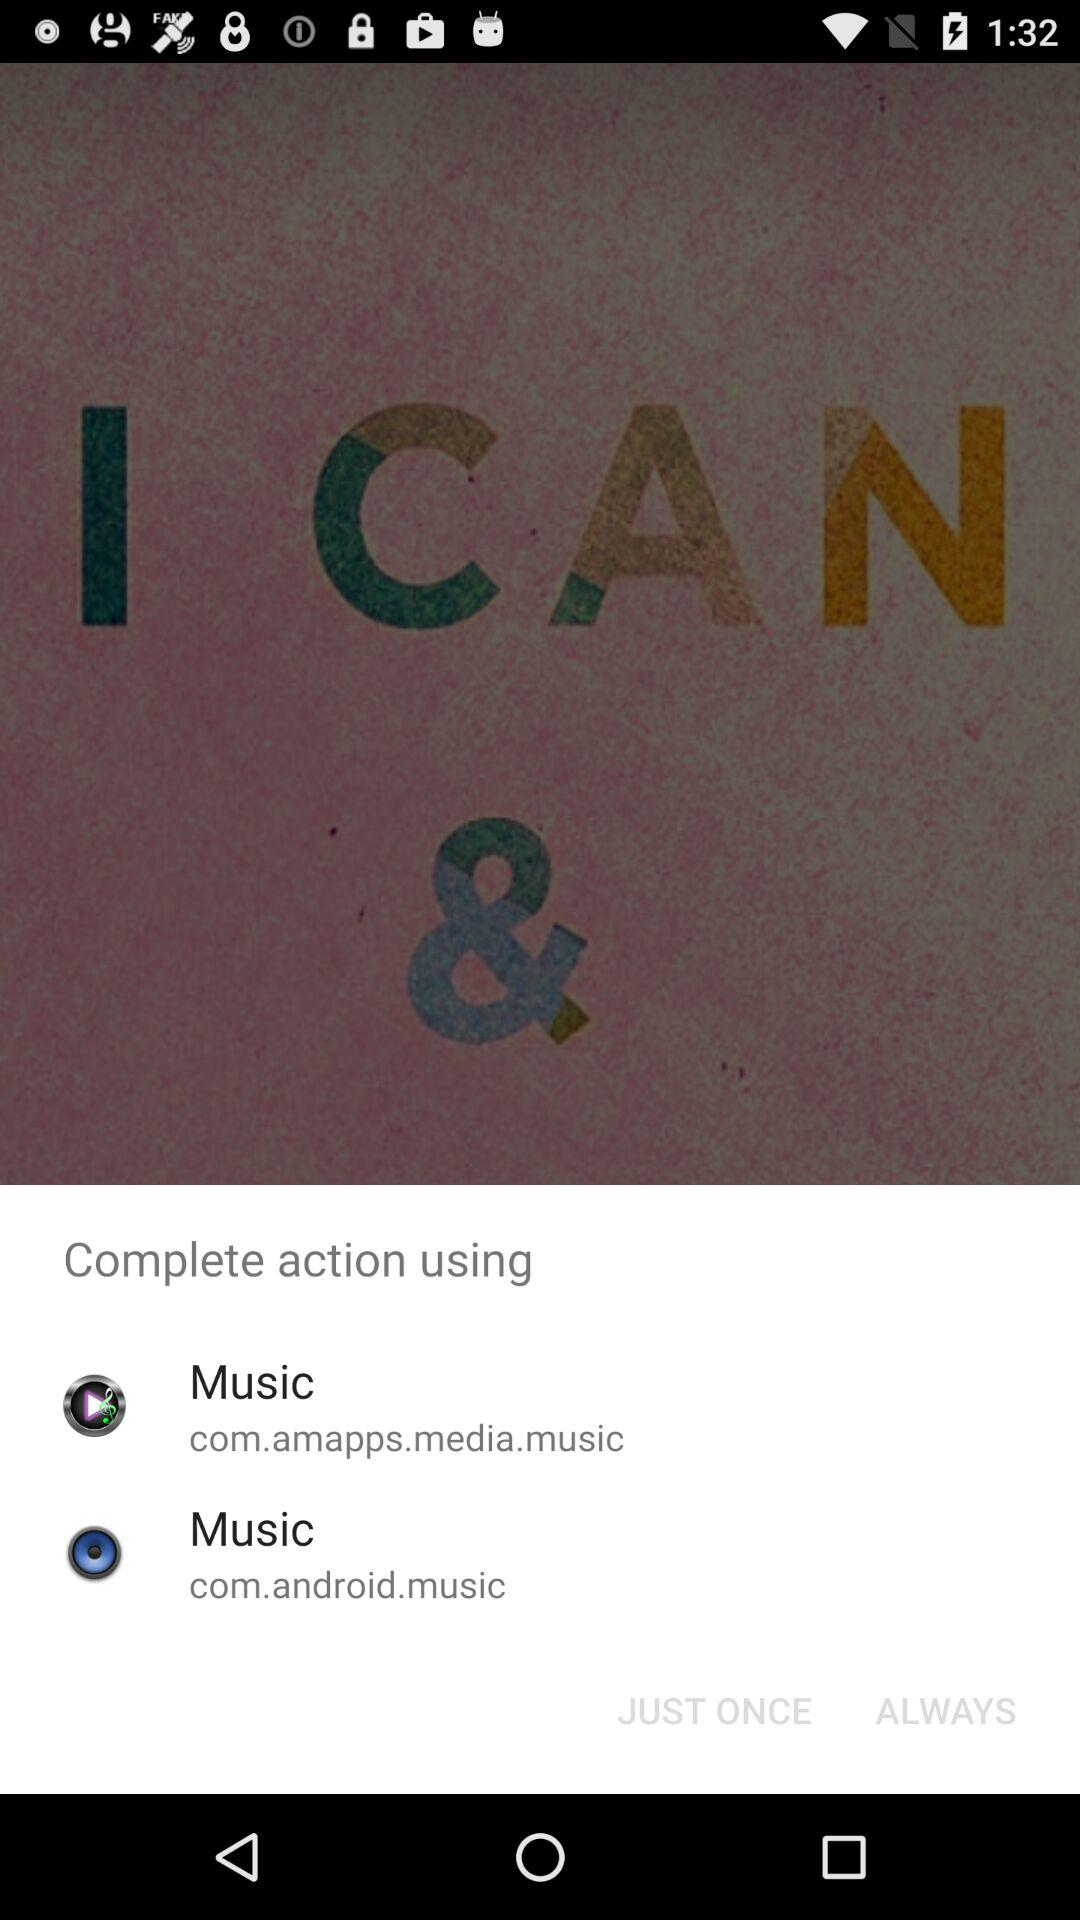Through which application can we open the content? You can open the content through "Music" and "Music". 